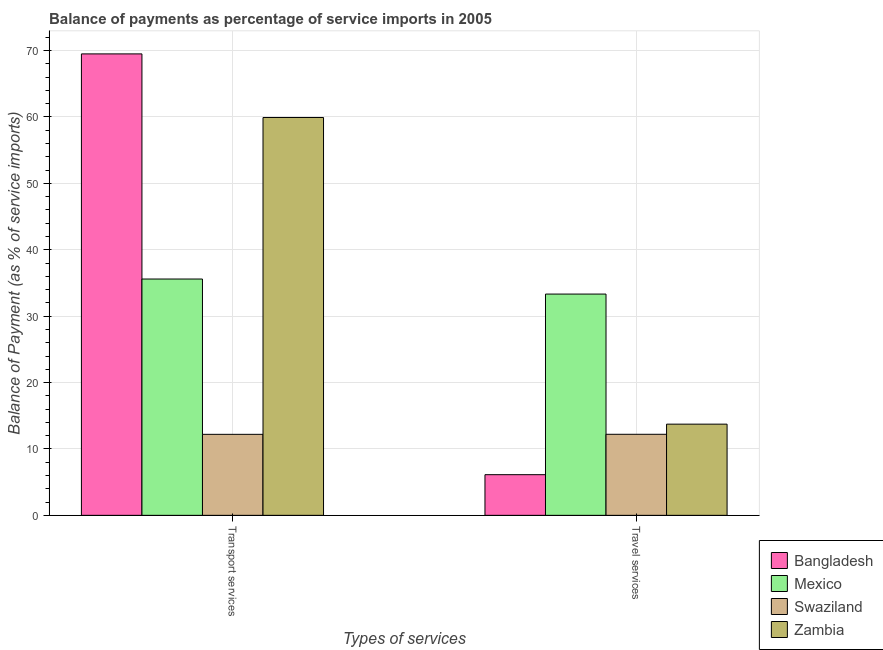How many different coloured bars are there?
Offer a terse response. 4. Are the number of bars per tick equal to the number of legend labels?
Give a very brief answer. Yes. What is the label of the 1st group of bars from the left?
Your response must be concise. Transport services. What is the balance of payments of travel services in Mexico?
Your answer should be very brief. 33.33. Across all countries, what is the maximum balance of payments of transport services?
Your response must be concise. 69.5. Across all countries, what is the minimum balance of payments of travel services?
Provide a succinct answer. 6.13. In which country was the balance of payments of transport services minimum?
Your answer should be compact. Swaziland. What is the total balance of payments of travel services in the graph?
Offer a very short reply. 65.4. What is the difference between the balance of payments of transport services in Mexico and that in Zambia?
Keep it short and to the point. -24.33. What is the difference between the balance of payments of travel services in Zambia and the balance of payments of transport services in Mexico?
Provide a succinct answer. -21.86. What is the average balance of payments of travel services per country?
Your answer should be compact. 16.35. What is the difference between the balance of payments of travel services and balance of payments of transport services in Mexico?
Offer a terse response. -2.27. In how many countries, is the balance of payments of travel services greater than 10 %?
Offer a very short reply. 3. What is the ratio of the balance of payments of transport services in Bangladesh to that in Swaziland?
Your answer should be very brief. 5.7. Is the balance of payments of travel services in Bangladesh less than that in Zambia?
Offer a terse response. Yes. What does the 3rd bar from the left in Transport services represents?
Your response must be concise. Swaziland. What does the 1st bar from the right in Travel services represents?
Provide a short and direct response. Zambia. How many bars are there?
Your response must be concise. 8. What is the difference between two consecutive major ticks on the Y-axis?
Keep it short and to the point. 10. Does the graph contain any zero values?
Make the answer very short. No. What is the title of the graph?
Your response must be concise. Balance of payments as percentage of service imports in 2005. What is the label or title of the X-axis?
Offer a very short reply. Types of services. What is the label or title of the Y-axis?
Ensure brevity in your answer.  Balance of Payment (as % of service imports). What is the Balance of Payment (as % of service imports) in Bangladesh in Transport services?
Provide a short and direct response. 69.5. What is the Balance of Payment (as % of service imports) of Mexico in Transport services?
Give a very brief answer. 35.6. What is the Balance of Payment (as % of service imports) in Swaziland in Transport services?
Offer a very short reply. 12.2. What is the Balance of Payment (as % of service imports) in Zambia in Transport services?
Keep it short and to the point. 59.93. What is the Balance of Payment (as % of service imports) in Bangladesh in Travel services?
Provide a succinct answer. 6.13. What is the Balance of Payment (as % of service imports) of Mexico in Travel services?
Your response must be concise. 33.33. What is the Balance of Payment (as % of service imports) of Swaziland in Travel services?
Offer a very short reply. 12.21. What is the Balance of Payment (as % of service imports) of Zambia in Travel services?
Your answer should be very brief. 13.74. Across all Types of services, what is the maximum Balance of Payment (as % of service imports) in Bangladesh?
Give a very brief answer. 69.5. Across all Types of services, what is the maximum Balance of Payment (as % of service imports) of Mexico?
Give a very brief answer. 35.6. Across all Types of services, what is the maximum Balance of Payment (as % of service imports) of Swaziland?
Give a very brief answer. 12.21. Across all Types of services, what is the maximum Balance of Payment (as % of service imports) of Zambia?
Keep it short and to the point. 59.93. Across all Types of services, what is the minimum Balance of Payment (as % of service imports) in Bangladesh?
Offer a terse response. 6.13. Across all Types of services, what is the minimum Balance of Payment (as % of service imports) of Mexico?
Offer a terse response. 33.33. Across all Types of services, what is the minimum Balance of Payment (as % of service imports) of Swaziland?
Ensure brevity in your answer.  12.2. Across all Types of services, what is the minimum Balance of Payment (as % of service imports) in Zambia?
Your answer should be compact. 13.74. What is the total Balance of Payment (as % of service imports) of Bangladesh in the graph?
Give a very brief answer. 75.63. What is the total Balance of Payment (as % of service imports) in Mexico in the graph?
Your answer should be very brief. 68.93. What is the total Balance of Payment (as % of service imports) in Swaziland in the graph?
Your answer should be compact. 24.41. What is the total Balance of Payment (as % of service imports) in Zambia in the graph?
Your answer should be very brief. 73.66. What is the difference between the Balance of Payment (as % of service imports) of Bangladesh in Transport services and that in Travel services?
Make the answer very short. 63.38. What is the difference between the Balance of Payment (as % of service imports) in Mexico in Transport services and that in Travel services?
Give a very brief answer. 2.27. What is the difference between the Balance of Payment (as % of service imports) in Swaziland in Transport services and that in Travel services?
Ensure brevity in your answer.  -0.01. What is the difference between the Balance of Payment (as % of service imports) of Zambia in Transport services and that in Travel services?
Ensure brevity in your answer.  46.19. What is the difference between the Balance of Payment (as % of service imports) of Bangladesh in Transport services and the Balance of Payment (as % of service imports) of Mexico in Travel services?
Offer a terse response. 36.18. What is the difference between the Balance of Payment (as % of service imports) of Bangladesh in Transport services and the Balance of Payment (as % of service imports) of Swaziland in Travel services?
Make the answer very short. 57.3. What is the difference between the Balance of Payment (as % of service imports) of Bangladesh in Transport services and the Balance of Payment (as % of service imports) of Zambia in Travel services?
Give a very brief answer. 55.77. What is the difference between the Balance of Payment (as % of service imports) in Mexico in Transport services and the Balance of Payment (as % of service imports) in Swaziland in Travel services?
Your response must be concise. 23.39. What is the difference between the Balance of Payment (as % of service imports) in Mexico in Transport services and the Balance of Payment (as % of service imports) in Zambia in Travel services?
Ensure brevity in your answer.  21.86. What is the difference between the Balance of Payment (as % of service imports) in Swaziland in Transport services and the Balance of Payment (as % of service imports) in Zambia in Travel services?
Your answer should be compact. -1.53. What is the average Balance of Payment (as % of service imports) of Bangladesh per Types of services?
Offer a terse response. 37.82. What is the average Balance of Payment (as % of service imports) of Mexico per Types of services?
Your response must be concise. 34.46. What is the average Balance of Payment (as % of service imports) of Swaziland per Types of services?
Your answer should be very brief. 12.21. What is the average Balance of Payment (as % of service imports) in Zambia per Types of services?
Your answer should be very brief. 36.83. What is the difference between the Balance of Payment (as % of service imports) in Bangladesh and Balance of Payment (as % of service imports) in Mexico in Transport services?
Your response must be concise. 33.91. What is the difference between the Balance of Payment (as % of service imports) of Bangladesh and Balance of Payment (as % of service imports) of Swaziland in Transport services?
Provide a short and direct response. 57.3. What is the difference between the Balance of Payment (as % of service imports) in Bangladesh and Balance of Payment (as % of service imports) in Zambia in Transport services?
Offer a terse response. 9.58. What is the difference between the Balance of Payment (as % of service imports) of Mexico and Balance of Payment (as % of service imports) of Swaziland in Transport services?
Your answer should be very brief. 23.39. What is the difference between the Balance of Payment (as % of service imports) of Mexico and Balance of Payment (as % of service imports) of Zambia in Transport services?
Offer a terse response. -24.33. What is the difference between the Balance of Payment (as % of service imports) of Swaziland and Balance of Payment (as % of service imports) of Zambia in Transport services?
Your answer should be compact. -47.73. What is the difference between the Balance of Payment (as % of service imports) of Bangladesh and Balance of Payment (as % of service imports) of Mexico in Travel services?
Ensure brevity in your answer.  -27.2. What is the difference between the Balance of Payment (as % of service imports) in Bangladesh and Balance of Payment (as % of service imports) in Swaziland in Travel services?
Offer a terse response. -6.08. What is the difference between the Balance of Payment (as % of service imports) of Bangladesh and Balance of Payment (as % of service imports) of Zambia in Travel services?
Give a very brief answer. -7.61. What is the difference between the Balance of Payment (as % of service imports) of Mexico and Balance of Payment (as % of service imports) of Swaziland in Travel services?
Provide a succinct answer. 21.12. What is the difference between the Balance of Payment (as % of service imports) in Mexico and Balance of Payment (as % of service imports) in Zambia in Travel services?
Your response must be concise. 19.59. What is the difference between the Balance of Payment (as % of service imports) of Swaziland and Balance of Payment (as % of service imports) of Zambia in Travel services?
Your answer should be very brief. -1.53. What is the ratio of the Balance of Payment (as % of service imports) in Bangladesh in Transport services to that in Travel services?
Make the answer very short. 11.35. What is the ratio of the Balance of Payment (as % of service imports) in Mexico in Transport services to that in Travel services?
Your answer should be compact. 1.07. What is the ratio of the Balance of Payment (as % of service imports) of Swaziland in Transport services to that in Travel services?
Your answer should be very brief. 1. What is the ratio of the Balance of Payment (as % of service imports) of Zambia in Transport services to that in Travel services?
Offer a terse response. 4.36. What is the difference between the highest and the second highest Balance of Payment (as % of service imports) in Bangladesh?
Ensure brevity in your answer.  63.38. What is the difference between the highest and the second highest Balance of Payment (as % of service imports) of Mexico?
Give a very brief answer. 2.27. What is the difference between the highest and the second highest Balance of Payment (as % of service imports) in Swaziland?
Your response must be concise. 0.01. What is the difference between the highest and the second highest Balance of Payment (as % of service imports) of Zambia?
Make the answer very short. 46.19. What is the difference between the highest and the lowest Balance of Payment (as % of service imports) of Bangladesh?
Ensure brevity in your answer.  63.38. What is the difference between the highest and the lowest Balance of Payment (as % of service imports) in Mexico?
Ensure brevity in your answer.  2.27. What is the difference between the highest and the lowest Balance of Payment (as % of service imports) of Swaziland?
Offer a terse response. 0.01. What is the difference between the highest and the lowest Balance of Payment (as % of service imports) in Zambia?
Give a very brief answer. 46.19. 